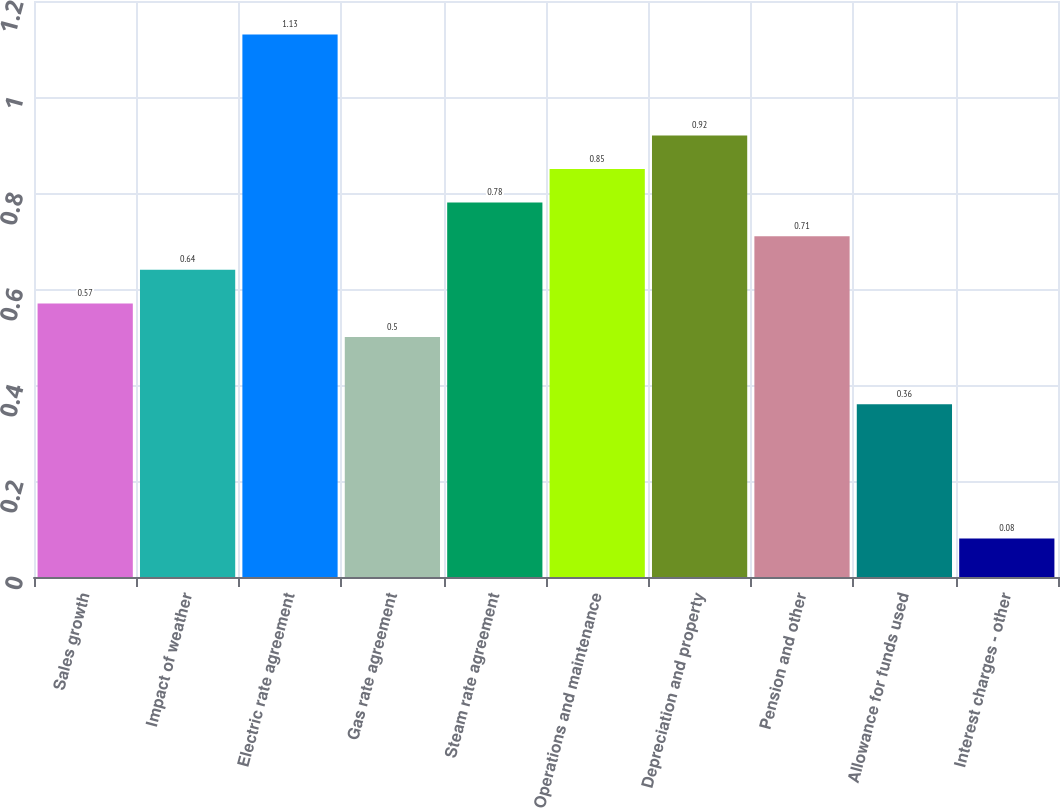Convert chart to OTSL. <chart><loc_0><loc_0><loc_500><loc_500><bar_chart><fcel>Sales growth<fcel>Impact of weather<fcel>Electric rate agreement<fcel>Gas rate agreement<fcel>Steam rate agreement<fcel>Operations and maintenance<fcel>Depreciation and property<fcel>Pension and other<fcel>Allowance for funds used<fcel>Interest charges - other<nl><fcel>0.57<fcel>0.64<fcel>1.13<fcel>0.5<fcel>0.78<fcel>0.85<fcel>0.92<fcel>0.71<fcel>0.36<fcel>0.08<nl></chart> 